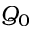<formula> <loc_0><loc_0><loc_500><loc_500>Q _ { 0 }</formula> 